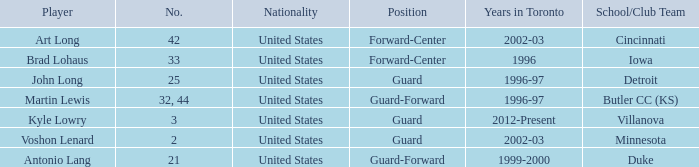What position does the player who played for butler cc (ks) play? Guard-Forward. 